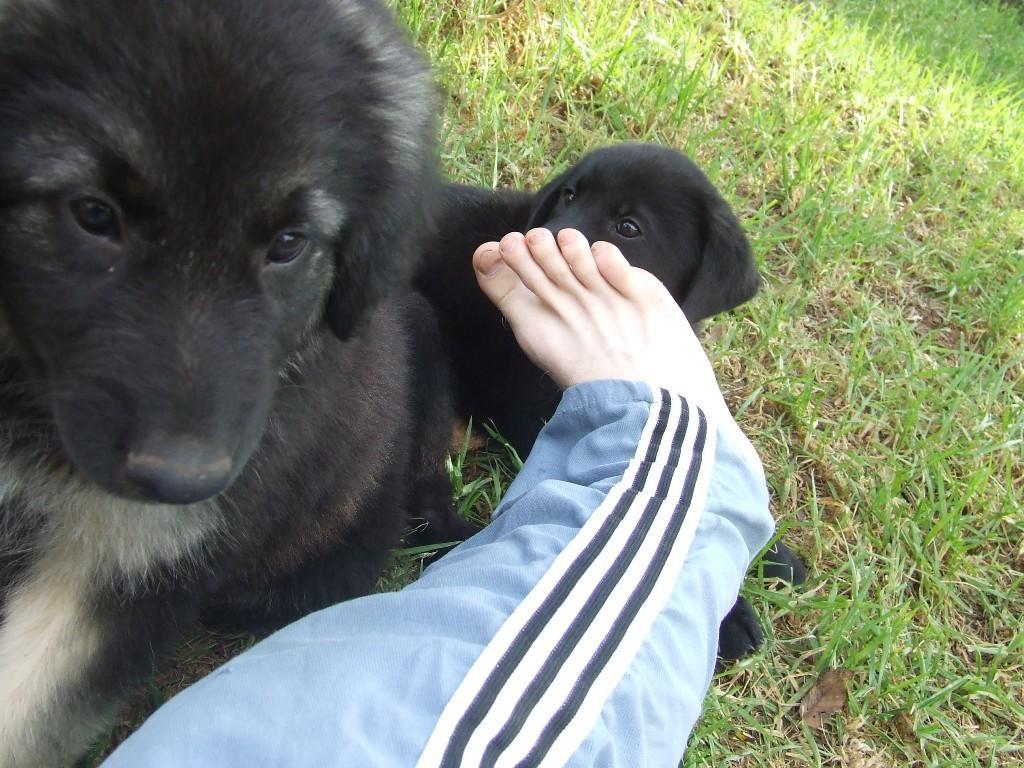Describe this image in one or two sentences. In this image we can see the dogs on the grass. And we can see a person's leg on the dog. 